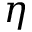<formula> <loc_0><loc_0><loc_500><loc_500>\eta</formula> 